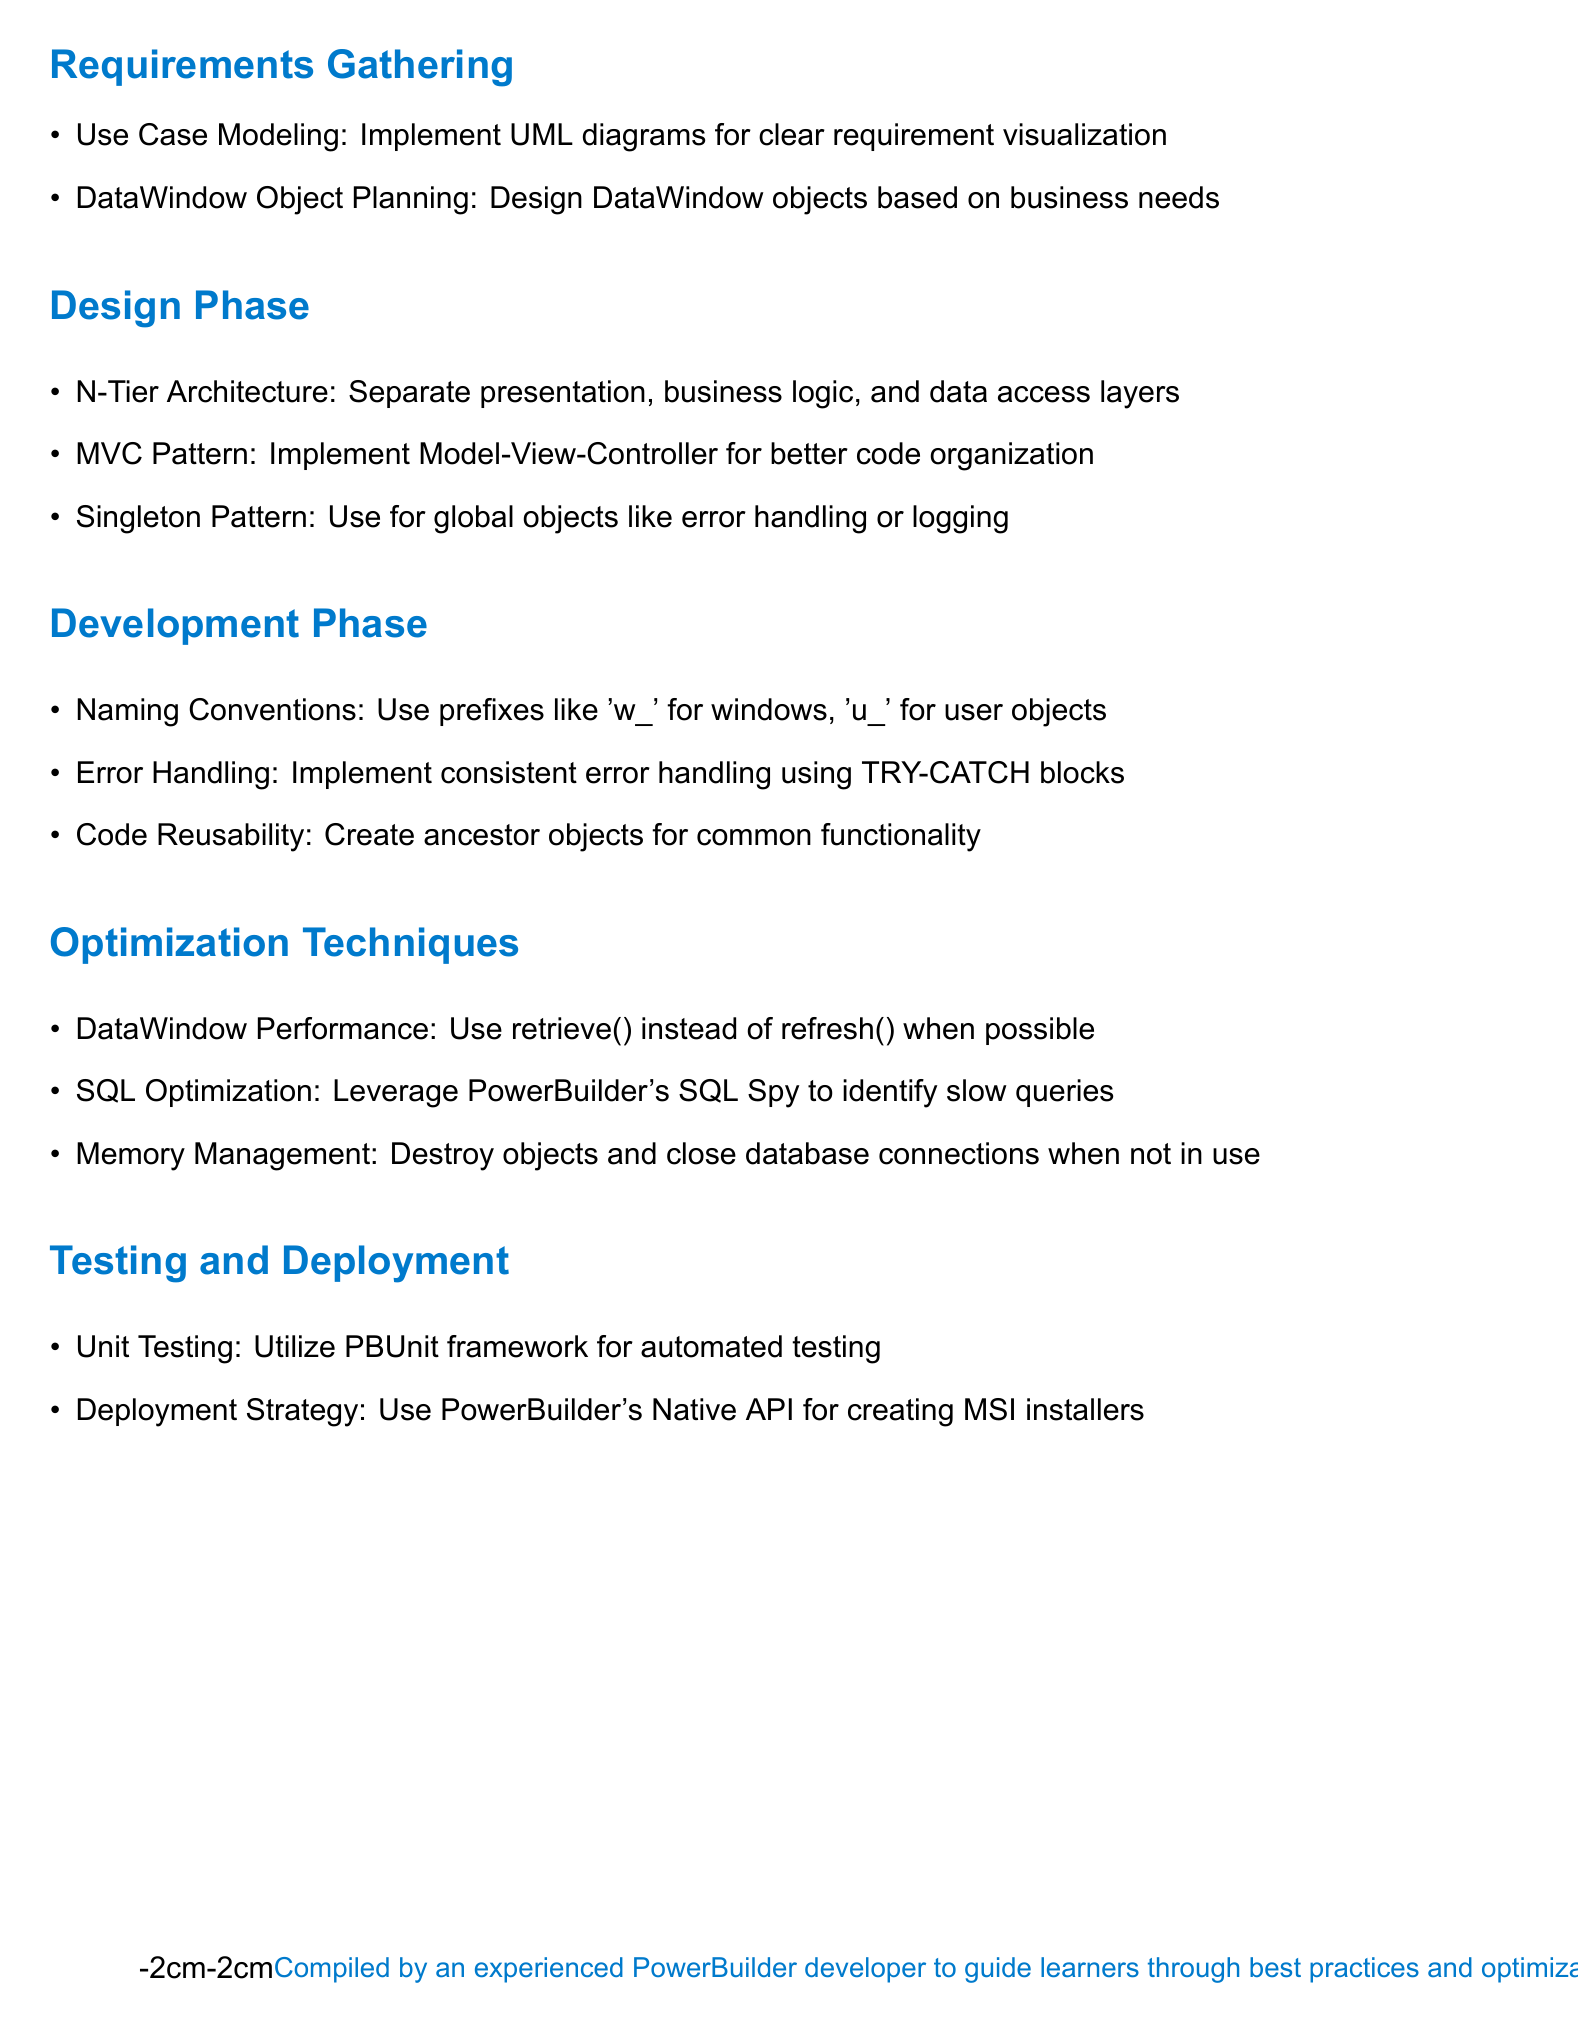What is the title of the document? The title provides insight into the content and focus of the document, which is on best practices and techniques in PowerBuilder.
Answer: PowerBuilder Best Practices, Design Patterns, and Optimization Techniques How many main phases are outlined in the document? The document is structured into various development phases, explicitly listing them for clear guidance.
Answer: Five What is one technique recommended for the Requirements Gathering phase? The document suggests specific methods for effective requirement gathering that can improve project clarity and direction.
Answer: Use Case Modeling What design pattern is emphasized in the Design Phase? The document mentions patterns that aid in structuring code effectively during the design phase, which can enhance maintainability and readability.
Answer: MVC Pattern What is the purpose of using the PBUnit framework? The document highlights the significance of testing in software development and tools that aid in ensuring code quality.
Answer: Unit Testing What does the document recommend for DataWindow performance? The document provides practical optimization techniques that developers can implement to improve application performance.
Answer: Use retrieve() instead of refresh() Which strategy is suggested for deployment? The document lays out a specific approach for deploying applications effectively within PowerBuilder.
Answer: Use PowerBuilder's Native API What type of architecture does the document recommend? The architecture mentioned in the document is essential for structuring applications effectively and ensuring separation of concerns.
Answer: N-Tier Architecture 